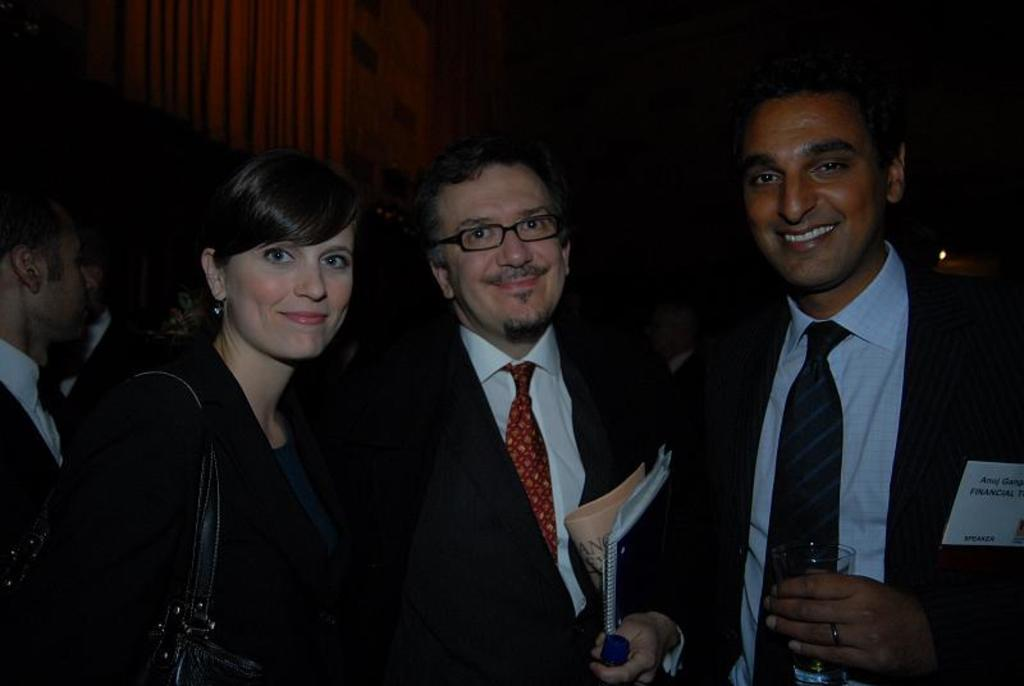How many people are in the image? There is a group of people in the image. What are some of the people doing in the image? Some people are holding objects, and three people are smiling and looking at something. What can be observed about the background of the image? The background of the image has a dark view. Where is the airplane located in the image? There is no airplane present in the image. What type of lunchroom can be seen in the image? There is no lunchroom present in the image. 